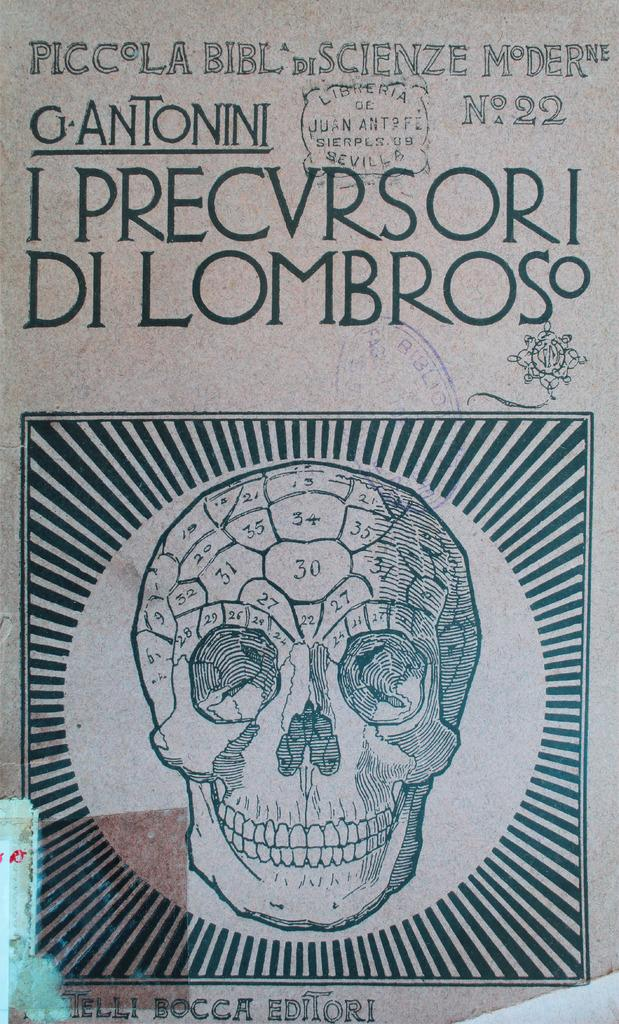<image>
Write a terse but informative summary of the picture. PiccolaBibl di ScienzeModerne number 22 design on paper. 